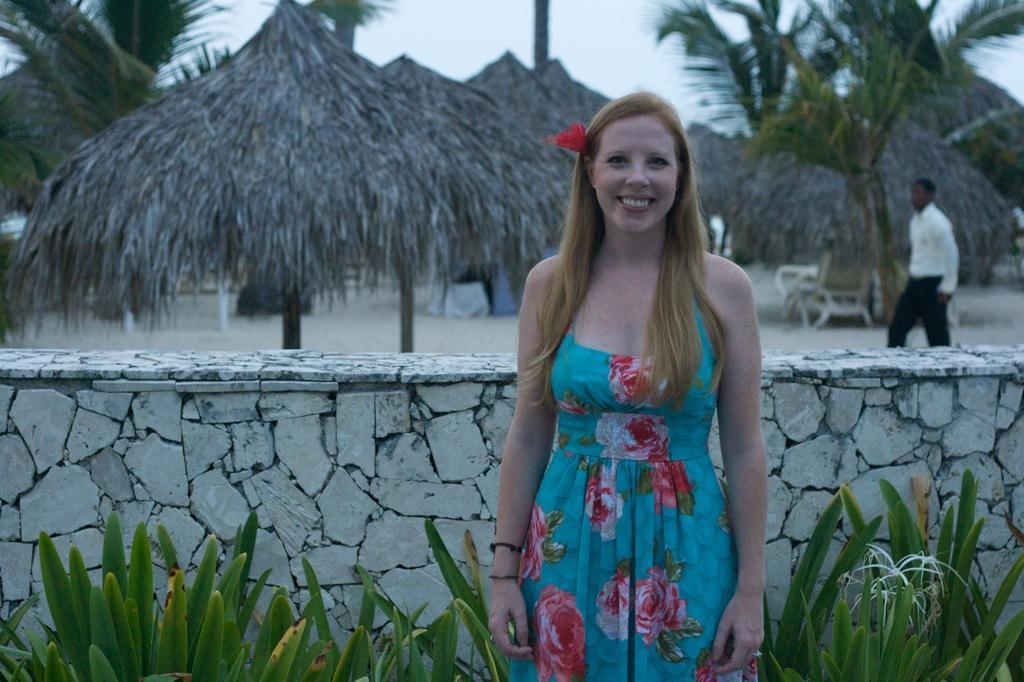How would you summarize this image in a sentence or two? In this image we can see a woman is standing, plants and wall. In the background we can see a person, trees, objects, wooden umbrellas and the sky. 